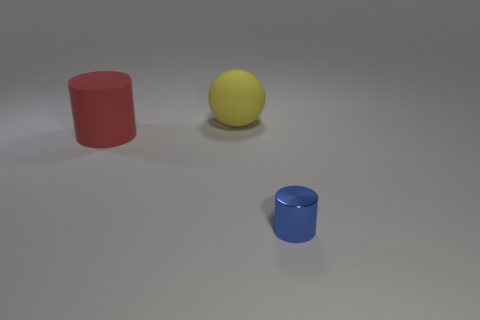Are there any shadows indicating the light source in the scene? Yes, faint shadows can be observed beneath the objects, slightly extending towards the right side of the image, suggesting that the light source is located to the left side above the scene. 